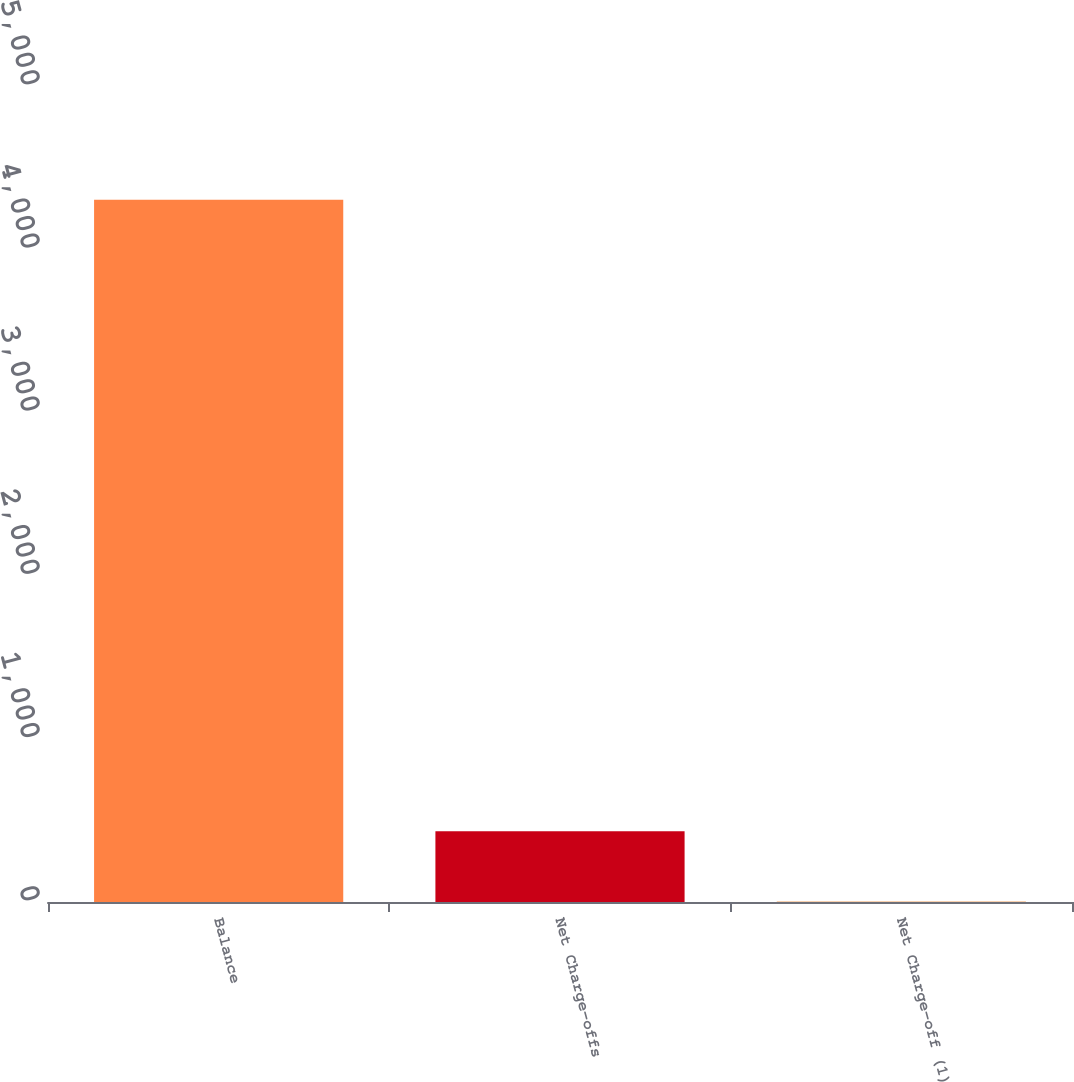Convert chart to OTSL. <chart><loc_0><loc_0><loc_500><loc_500><bar_chart><fcel>Balance<fcel>Net Charge-offs<fcel>Net Charge-off (1)<nl><fcel>4303<fcel>433.23<fcel>3.25<nl></chart> 